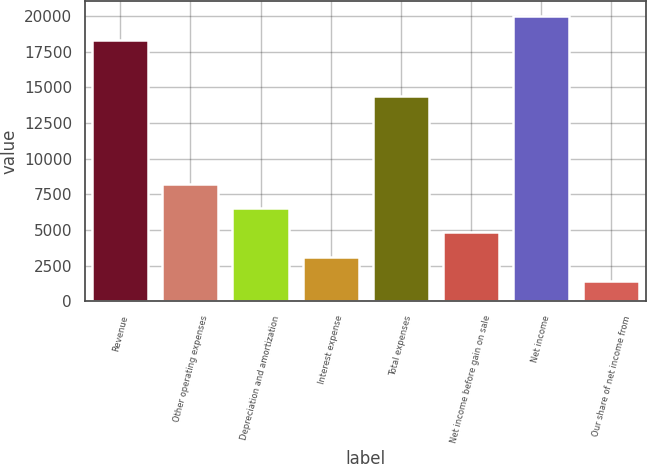Convert chart. <chart><loc_0><loc_0><loc_500><loc_500><bar_chart><fcel>Revenue<fcel>Other operating expenses<fcel>Depreciation and amortization<fcel>Interest expense<fcel>Total expenses<fcel>Net income before gain on sale<fcel>Net income<fcel>Our share of net income from<nl><fcel>18329<fcel>8234.2<fcel>6531.4<fcel>3125.8<fcel>14385<fcel>4828.6<fcel>20031.8<fcel>1423<nl></chart> 